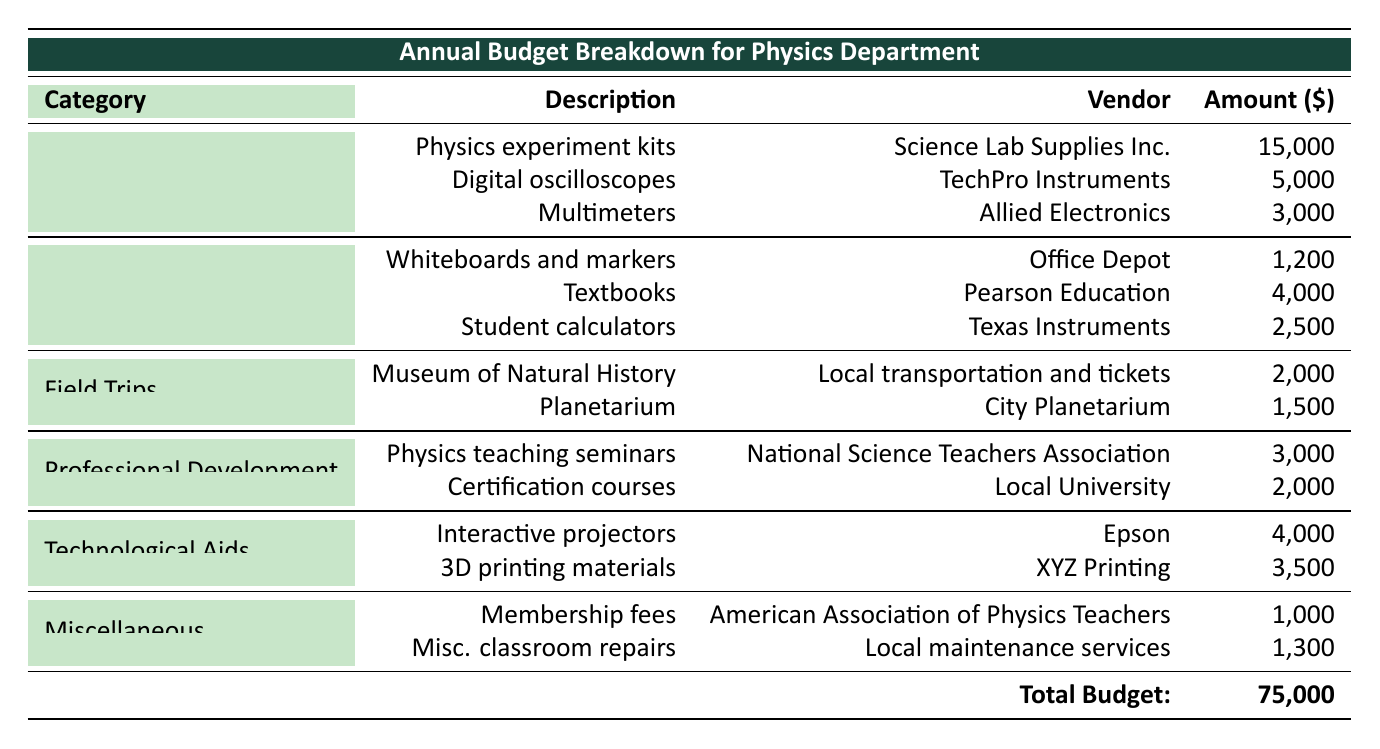What is the total budget for the Physics Department? The total budget is listed at the bottom of the table under "Total Budget," which states that the total amount is 75,000 dollars.
Answer: 75,000 How much is allocated for Lab Equipment? The table lists three items under Lab Equipment, with their amounts being 15,000, 5,000, and 3,000. Adding these amounts gives 15,000 + 5,000 + 3,000 = 23,000 dollars.
Answer: 23,000 Which vendor provided the Digital oscilloscopes? The item "Digital oscilloscopes" under "Lab Equipment" indicates that it was supplied by TechPro Instruments.
Answer: TechPro Instruments Is the amount allocated for Classroom Supplies greater than that for Technological Aids? The total for Classroom Supplies is 1,200 + 4,000 + 2,500 = 7,700 dollars, and for Technological Aids, it is 4,000 + 3,500 = 7,500 dollars. Since 7,700 is greater than 7,500, the statement is true.
Answer: Yes What is the total amount spent on field trips? There are two items listed for field trips: 2,000 dollars for the Museum of Natural History and 1,500 dollars for the Planetarium. Adding these gives 2,000 + 1,500 = 3,500 dollars.
Answer: 3,500 Which category has the highest total expenditure? By summing the amounts for each category, Lab Equipment totals 23,000, Classroom Supplies totals 7,700, Field Trips totals 3,500, Professional Development totals 5,000, Technological Aids totals 7,500, and Miscellaneous totals 2,300. The highest total is for Lab Equipment at 23,000 dollars.
Answer: Lab Equipment What is the average expenditure for the items in the Professional Development category? Professional Development has two items with amounts 3,000 and 2,000. The sum is 3,000 + 2,000 = 5,000, and there are two items. Therefore, the average is 5,000 / 2 = 2,500 dollars.
Answer: 2,500 How much is allocated for Miscellaneous expenses? The table shows two expenses under Miscellaneous: 1,000 dollars for membership fees and 1,300 dollars for miscellaneous classroom repairs. Adding these gives 1,000 + 1,300 = 2,300 dollars.
Answer: 2,300 Are textbooks the most expensive item under Classroom Supplies? The table shows that textbooks cost 4,000 dollars, while whiteboards and markers cost 1,200 dollars, and student calculators cost 2,500 dollars. Since 4,000 is the highest of these amounts, the statement is true.
Answer: Yes 